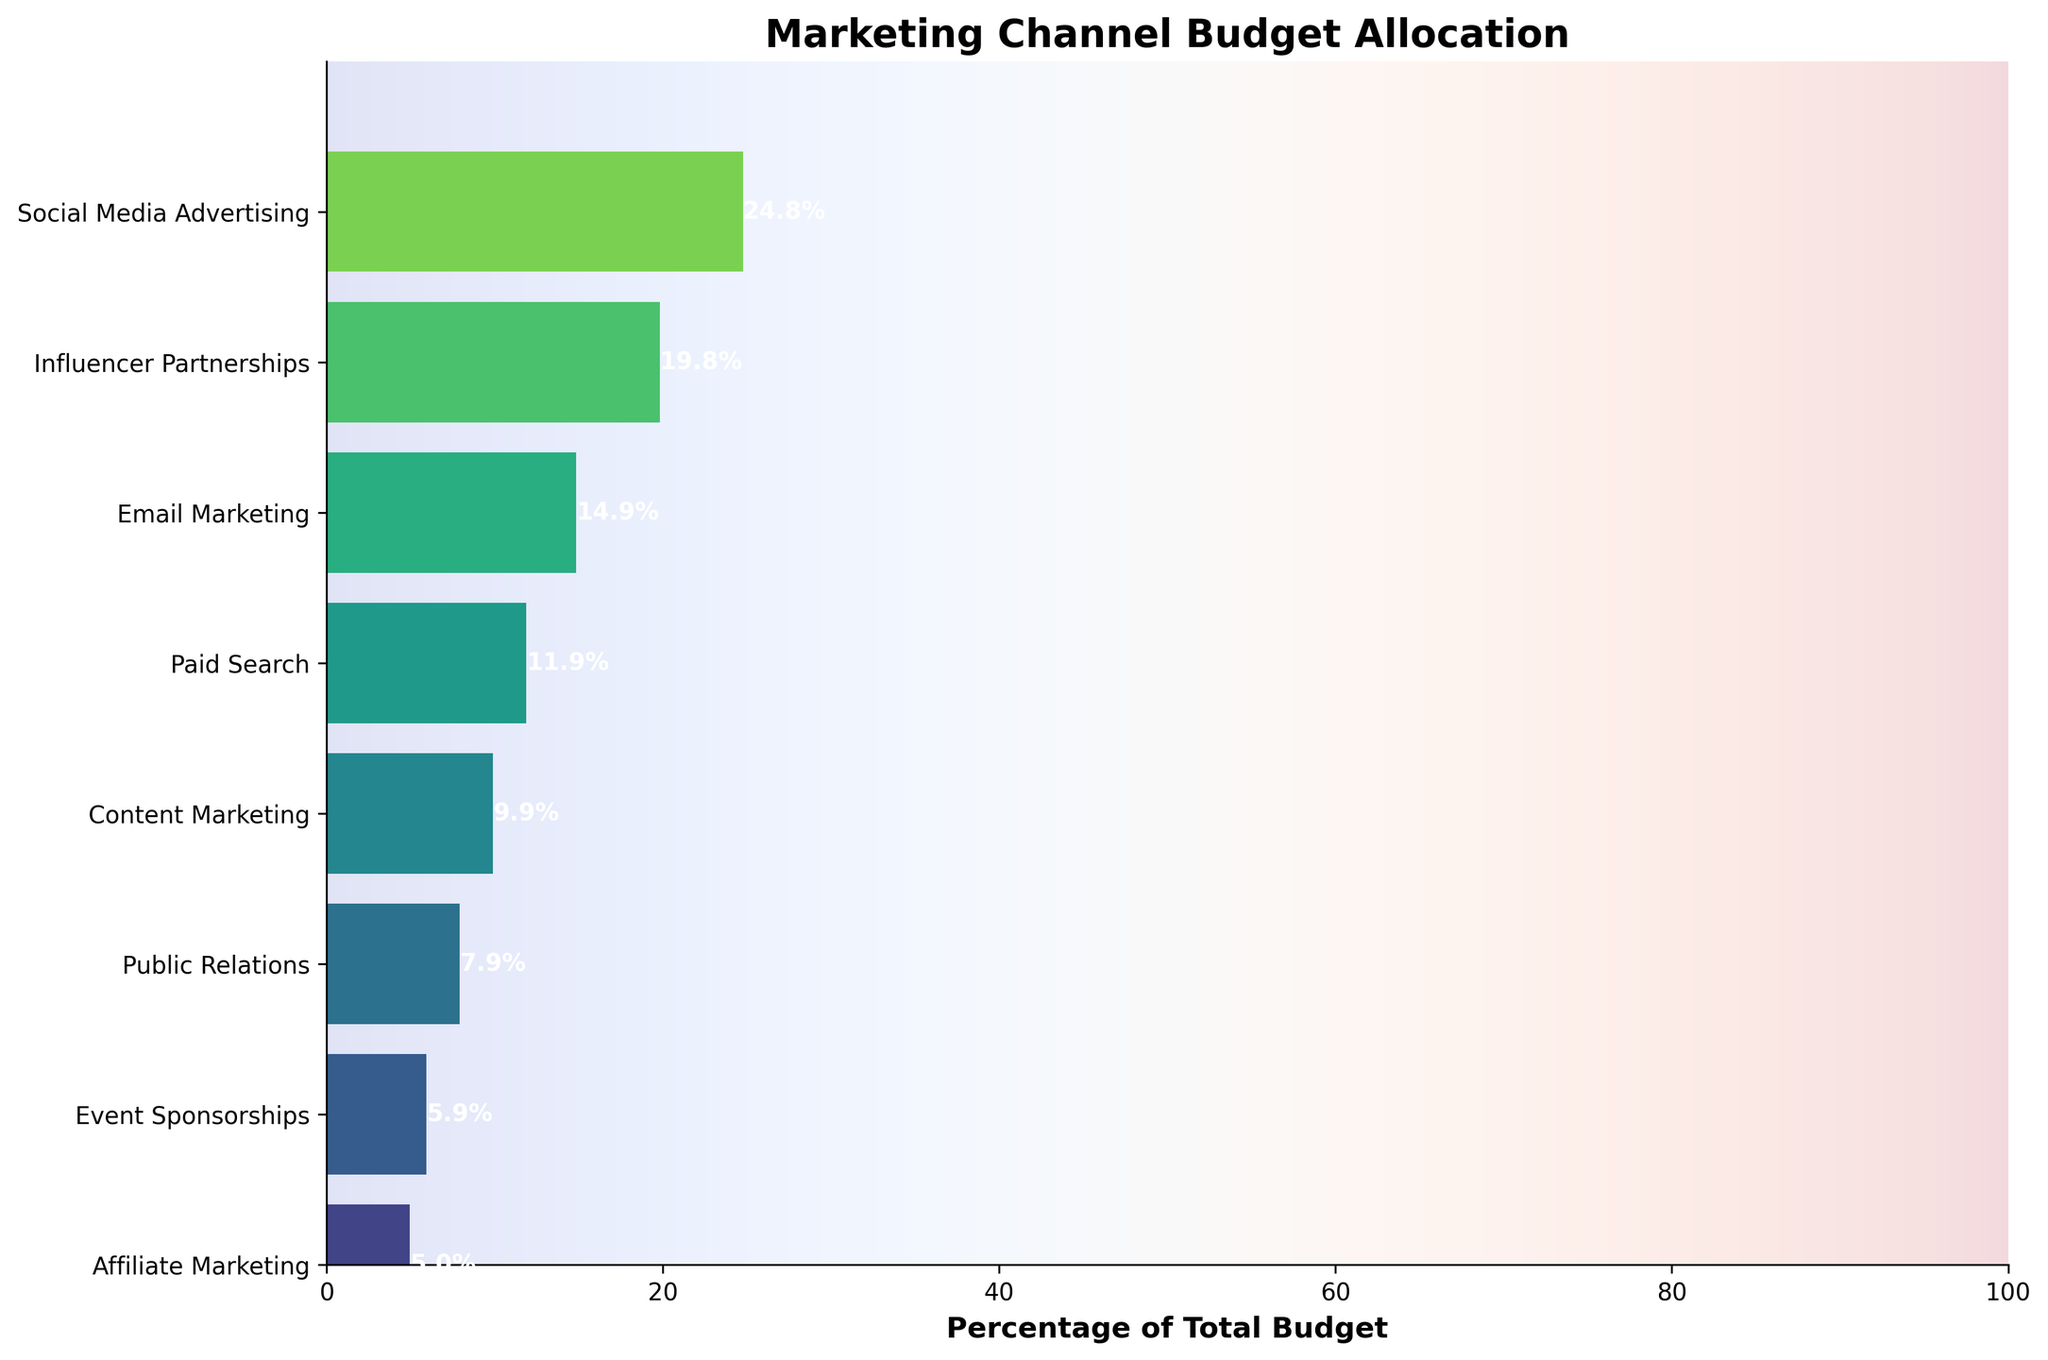What's the total budget allocated across all channels? To find the total budget, add the amounts allocated to each channel: $250,000 (Social Media Advertising) + $200,000 (Influencer Partnerships) + $150,000 (Email Marketing) + $120,000 (Paid Search) + $100,000 (Content Marketing) + $80,000 (Public Relations) + $60,000 (Event Sponsorships) + $50,000 (Affiliate Marketing) = $1,010,000
Answer: $1,010,000 Which marketing channel has the highest budget allocation? According to the figure, the longest bar represents Social Media Advertising, which assigns a budget of $250,000.
Answer: Social Media Advertising What's the percentage of the total budget allocated to Email Marketing? Email Marketing has a budget of $150,000. To find the percentage: (150,000 / 1,010,000) * 100 ≈ 14.9%
Answer: 14.9% How does the budget allocation for Influencer Partnerships compare to Paid Search? Influencer Partnerships receive $200,000, while Paid Search gets $120,000. So, Influencer Partnerships have a higher allocation.
Answer: Influencer Partnerships have higher allocation What is the cumulative budget percentage up to and including Content Marketing? Cumulative budget percentage is the sum of percentages up to Content Marketing. Summing the values: 24.8% (Social Media Advertising) + 19.8% (Influencer Partnerships) + 14.9% (Email Marketing) + 11.9% (Paid Search) + 9.9% (Content Marketing) ≈ 81.3%
Answer: 81.3% How much more budget does Paid Search have compared to Event Sponsorships? Paid Search has $120,000, and Event Sponsorships have $60,000. The difference is $120,000 - $60,000 = $60,000
Answer: $60,000 Which channel has the least budget allocation, and what percentage does it represent? The shortest bar corresponds to Affiliate Marketing, with a budget of $50,000. To find the percentage: (50,000 / 1,010,000) * 100 ≈ 5.0%
Answer: Affiliate Marketing, 5.0% Between Public Relations and Content Marketing, which has a higher allocation, and by how much? Public Relations has $80,000 and Content Marketing has $100,000. Content Marketing has $100,000 - $80,000 = $20,000 more.
Answer: Content Marketing by $20,000 What's the combined budget for Social Media Advertising, Influencer Partnerships, and Email Marketing? Add their budgets: $250,000 (Social Media Advertising) + $200,000 (Influencer Partnerships) + $150,000 (Email Marketing) = $600,000
Answer: $600,000 If we were to reduce the budget for Social Media Advertising by 10%, what would be the new total budget allocation? 10% of $250,000 is $25,000. The new Social Media Advertising budget would be $250,000 - $25,000 = $225,000. The new total budget is: $225,000 + ($1,010,000 - $250,000) = $985,000
Answer: $985,000 